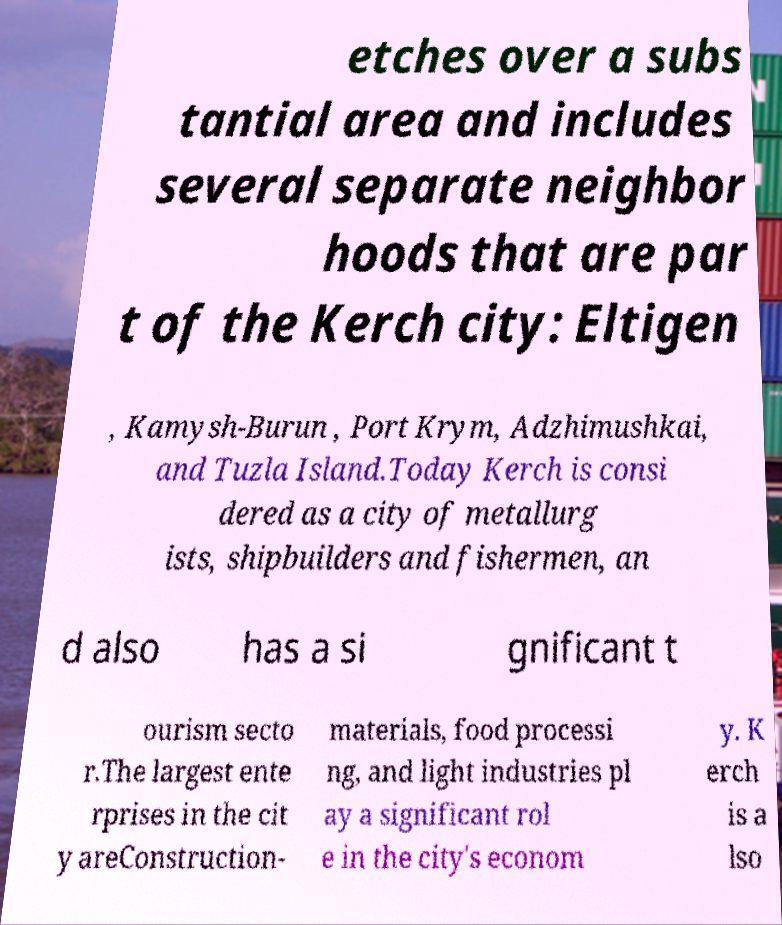Could you extract and type out the text from this image? etches over a subs tantial area and includes several separate neighbor hoods that are par t of the Kerch city: Eltigen , Kamysh-Burun , Port Krym, Adzhimushkai, and Tuzla Island.Today Kerch is consi dered as a city of metallurg ists, shipbuilders and fishermen, an d also has a si gnificant t ourism secto r.The largest ente rprises in the cit y areConstruction- materials, food processi ng, and light industries pl ay a significant rol e in the city's econom y. K erch is a lso 